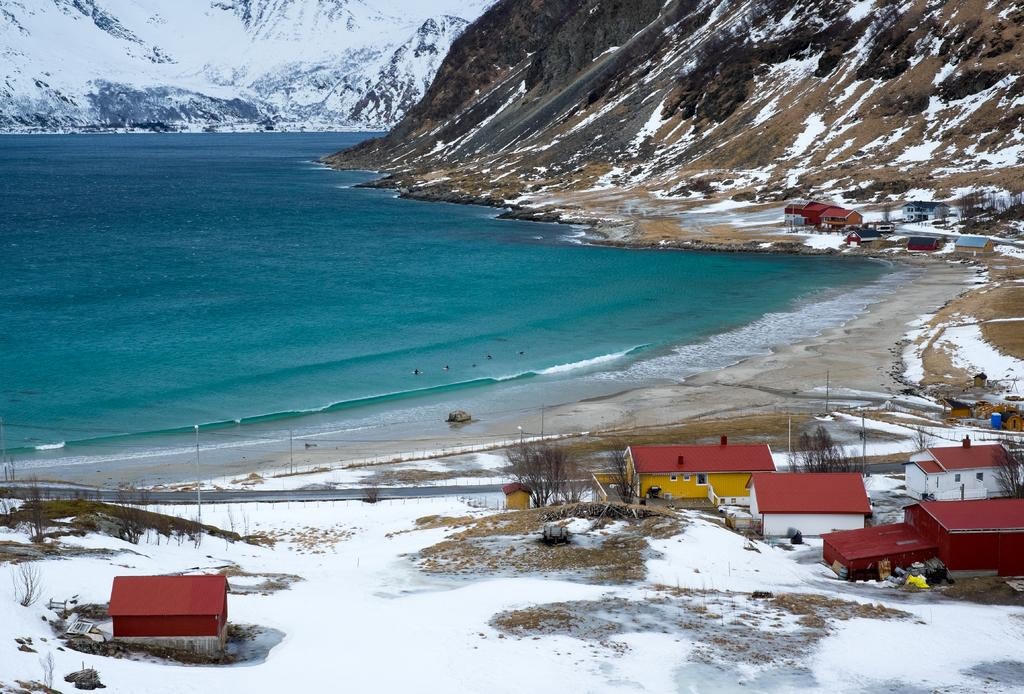What type of structures can be seen in the image? There are houses in the image. What is the condition of the land in the image? The land is covered with snow. What natural feature is present near the houses? There is a seashore in the image. What can be seen in the distance in the image? There are mountains and a sea visible in the background. What type of yam is growing in the patch near the houses? There is no yam or patch present in the image; the land is covered with snow. 